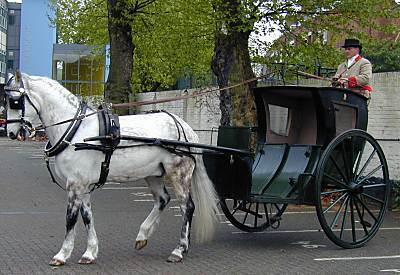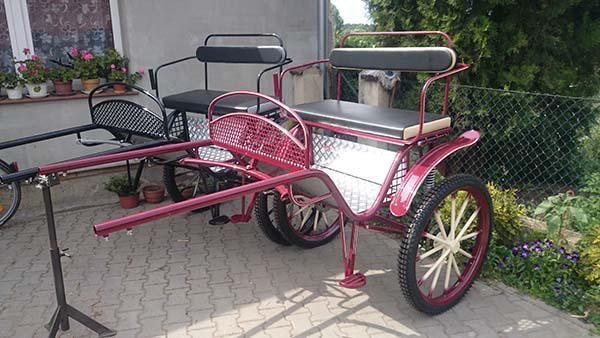The first image is the image on the left, the second image is the image on the right. Evaluate the accuracy of this statement regarding the images: "There at least one person shown in one or both of the images.". Is it true? Answer yes or no. Yes. The first image is the image on the left, the second image is the image on the right. Examine the images to the left and right. Is the description "One of the images has someone riding a horse carriage." accurate? Answer yes or no. Yes. 